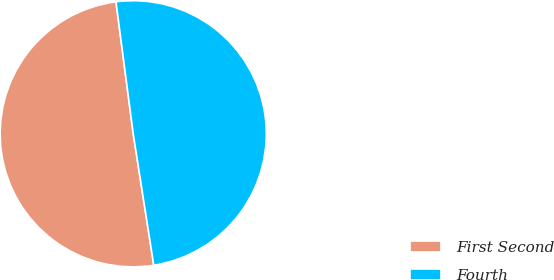Convert chart. <chart><loc_0><loc_0><loc_500><loc_500><pie_chart><fcel>First Second<fcel>Fourth<nl><fcel>50.4%<fcel>49.6%<nl></chart> 